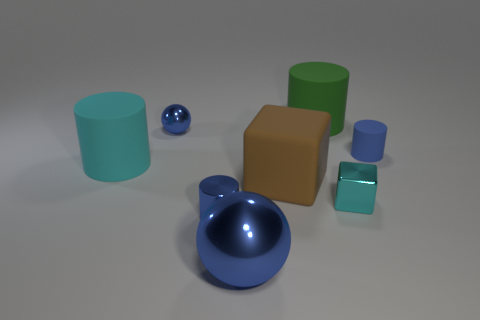Subtract all green cylinders. How many cylinders are left? 3 Subtract 1 cylinders. How many cylinders are left? 3 Subtract all gray cylinders. Subtract all green spheres. How many cylinders are left? 4 Add 2 blocks. How many objects exist? 10 Subtract all cubes. How many objects are left? 6 Subtract all green cylinders. Subtract all big cyan objects. How many objects are left? 6 Add 7 big metallic balls. How many big metallic balls are left? 8 Add 1 metal blocks. How many metal blocks exist? 2 Subtract 0 blue blocks. How many objects are left? 8 